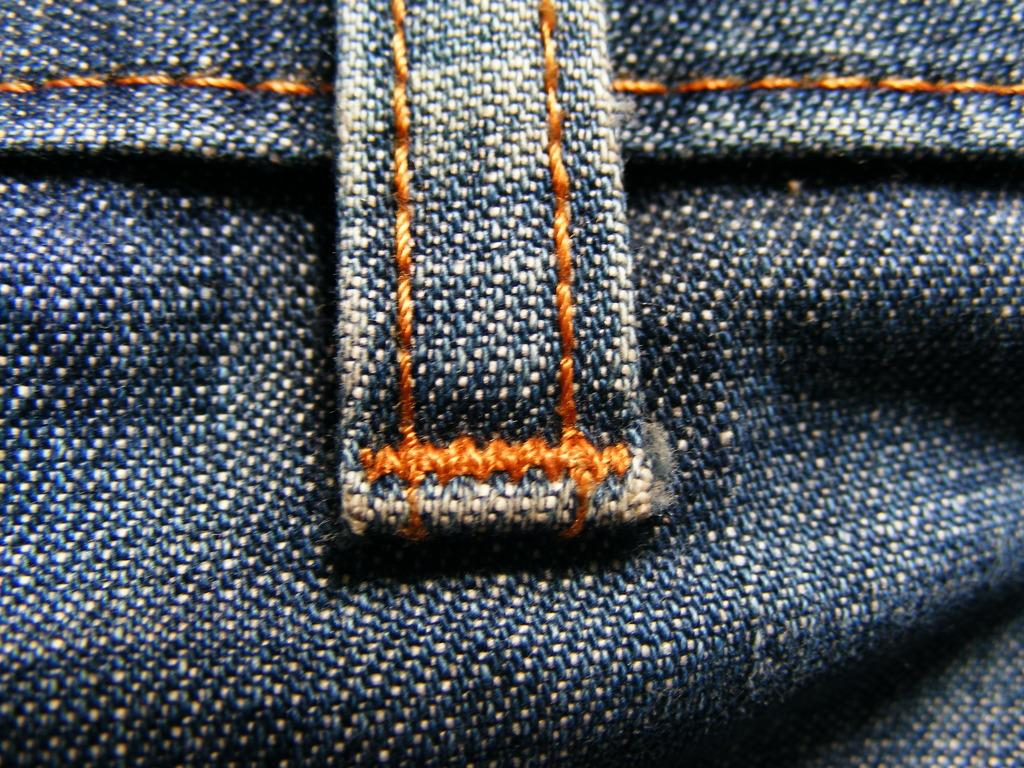What type of clothing is featured in the image? There is a jeans cloth in the image. Can you tell me how many donkeys are visible in the image? There are no donkeys present in the image; it features a jeans cloth. What type of throat condition is depicted in the image? There is no throat condition depicted in the image; it features a jeans cloth. 